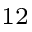<formula> <loc_0><loc_0><loc_500><loc_500>^ { 1 2 }</formula> 